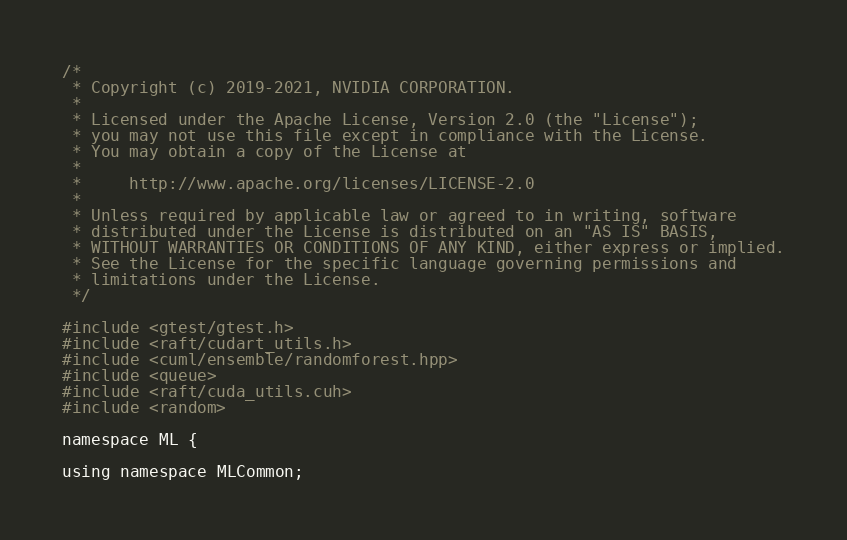<code> <loc_0><loc_0><loc_500><loc_500><_Cuda_>/*
 * Copyright (c) 2019-2021, NVIDIA CORPORATION.
 *
 * Licensed under the Apache License, Version 2.0 (the "License");
 * you may not use this file except in compliance with the License.
 * You may obtain a copy of the License at
 *
 *     http://www.apache.org/licenses/LICENSE-2.0
 *
 * Unless required by applicable law or agreed to in writing, software
 * distributed under the License is distributed on an "AS IS" BASIS,
 * WITHOUT WARRANTIES OR CONDITIONS OF ANY KIND, either express or implied.
 * See the License for the specific language governing permissions and
 * limitations under the License.
 */

#include <gtest/gtest.h>
#include <raft/cudart_utils.h>
#include <cuml/ensemble/randomforest.hpp>
#include <queue>
#include <raft/cuda_utils.cuh>
#include <random>

namespace ML {

using namespace MLCommon;
</code> 